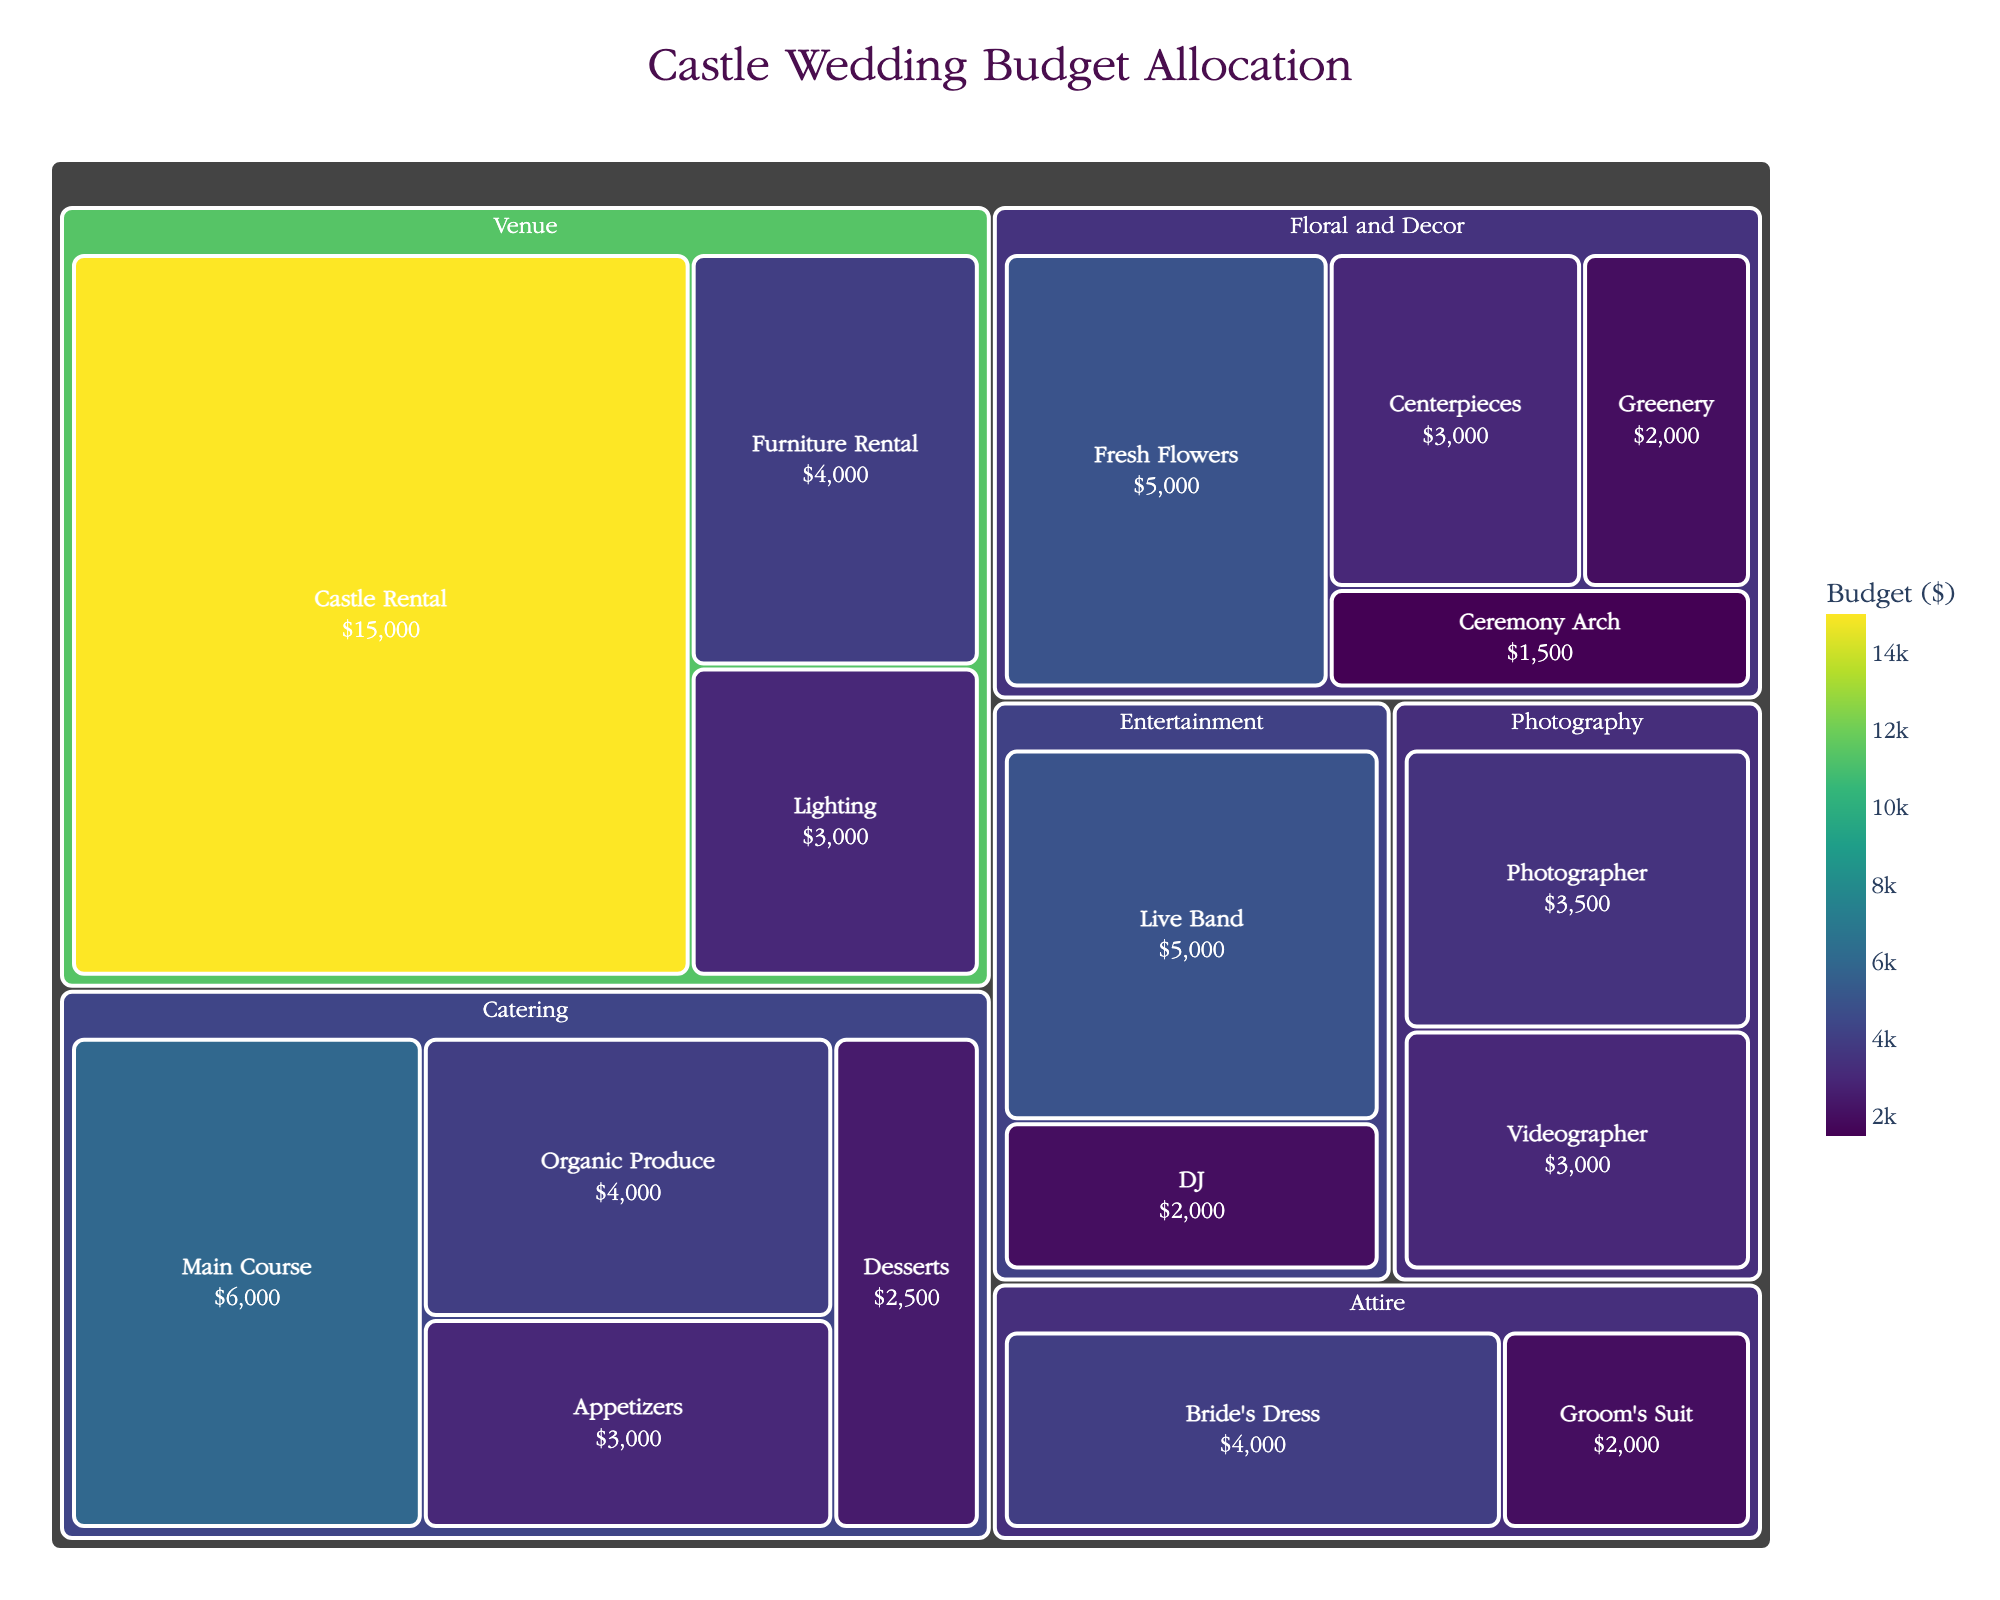what is the total budget allocated to the 'Catering' category? To find the total budget for 'Catering', sum up all subcategories under 'Catering': Organic Produce ($4000) + Main Course ($6000) + Appetizers ($3000) + Desserts ($2500) = $15500
Answer: $15500 how much more budget is allocated to 'Castle Rental' compared to 'Fresh Flowers'? The budget for 'Castle Rental' is $15000, and the budget for 'Fresh Flowers' is $5000. The difference is $15000 - $5000 = $10000.
Answer: $10000 what is the least expensive subcategory in the 'Attire' category? The two subcategories in 'Attire' are Bride's Dress ($4000) and Groom's Suit ($2000). The least expensive is Groom's Suit.
Answer: Groom's Suit which category has the highest total budget? By looking at the different categories, 'Venue' has the highest budget. 'Castle Rental' ($15000), 'Lighting' ($3000), and 'Furniture Rental' ($4000) sum up to $22000.
Answer: Venue what is the median budget allocation for the 'Floral and Decor' subcategories? For 'Floral and Decor', list the budgets in ascending order: Ceremony Arch ($1500), Greenery ($2000), Centerpieces ($3000), Fresh Flowers ($5000). The median is the average of the middle two values ($2000 and $3000): ($2000 + $3000) / 2 = $2500.
Answer: $2500 how much more is spent on the 'Bride's Dress' compared to the 'Groom's Suit'? The budget for the Bride's Dress is $4000 and for Groom's Suit is $2000. The difference is $4000 - $2000 = $2000.
Answer: $2000 are catering expenses more than entertainment expenses? Summing the 'Catering' subcategories gives us $15500. Summing the 'Entertainment' subcategories Live Band ($5000) + DJ ($2000) = $7000. Since $15500 is more than $7000, catering expenses are more.
Answer: Yes what percentage of the total budget is allocated to 'Photography'? First, find the total budget by summing all values. The total budget is $5000 + $2000 + $3000 + $1500 + $4000 + $6000 + $3000 + $2500 + $15000 + $3000 + $4000 + $5000 + $2000 + $4000 + $2000 + $3500 + $3000 = $68000. The photography budget is $3500 + $3000 = $6500. So, the percentage is ($6500/$68000) * 100 ≈ 9.56%.
Answer: 9.56% what is the absolute difference between the budgets of 'Live Band' and 'DJ'? The budget for Live Band is $5000, and for DJ is $2000. The absolute difference is $5000 - $2000 = $3000.
Answer: $3000 how many subcategories are there in total? Add up all the subcategories listed: Fresh Flowers, Greenery, Centerpieces, Ceremony Arch, Organic Produce, Main Course, Appetizers, Desserts, Castle Rental, Lighting, Furniture Rental, Live Band, DJ, Bride's Dress, Groom's Suit, Photographer, Videographer. This equals 17 subcategories.
Answer: 17 